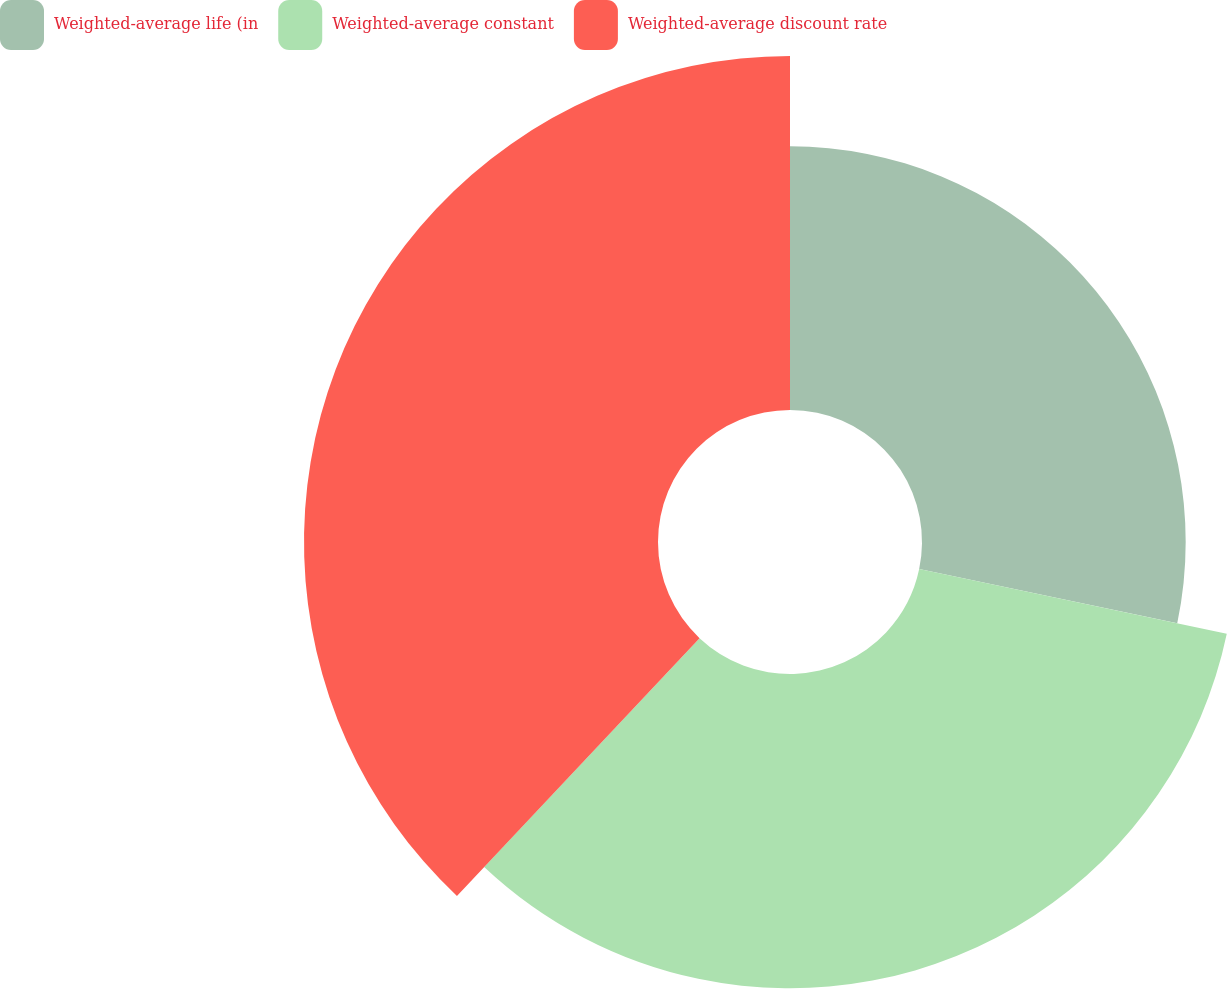<chart> <loc_0><loc_0><loc_500><loc_500><pie_chart><fcel>Weighted-average life (in<fcel>Weighted-average constant<fcel>Weighted-average discount rate<nl><fcel>28.29%<fcel>33.72%<fcel>37.98%<nl></chart> 